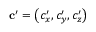<formula> <loc_0><loc_0><loc_500><loc_500>c ^ { \prime } = \left ( c _ { x } ^ { \prime } , c _ { y } ^ { \prime } , c _ { z } ^ { \prime } \right )</formula> 